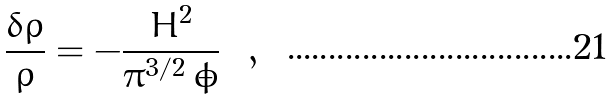<formula> <loc_0><loc_0><loc_500><loc_500>\frac { \delta \rho } { \rho } = - \frac { H ^ { 2 } } { \pi ^ { 3 / 2 } \, \dot { \phi } } \ \ ,</formula> 